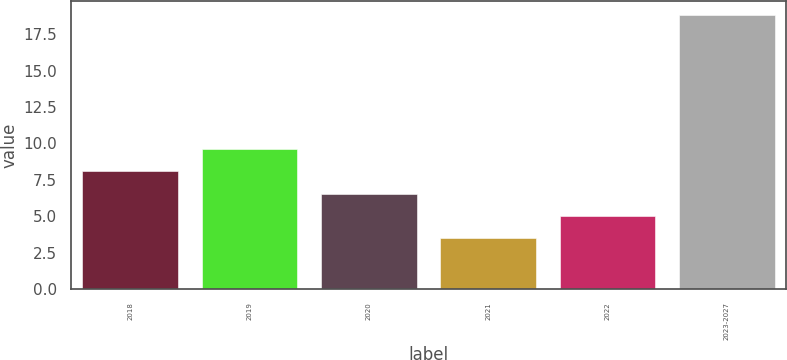Convert chart to OTSL. <chart><loc_0><loc_0><loc_500><loc_500><bar_chart><fcel>2018<fcel>2019<fcel>2020<fcel>2021<fcel>2022<fcel>2023-2027<nl><fcel>8.09<fcel>9.62<fcel>6.56<fcel>3.5<fcel>5.03<fcel>18.8<nl></chart> 